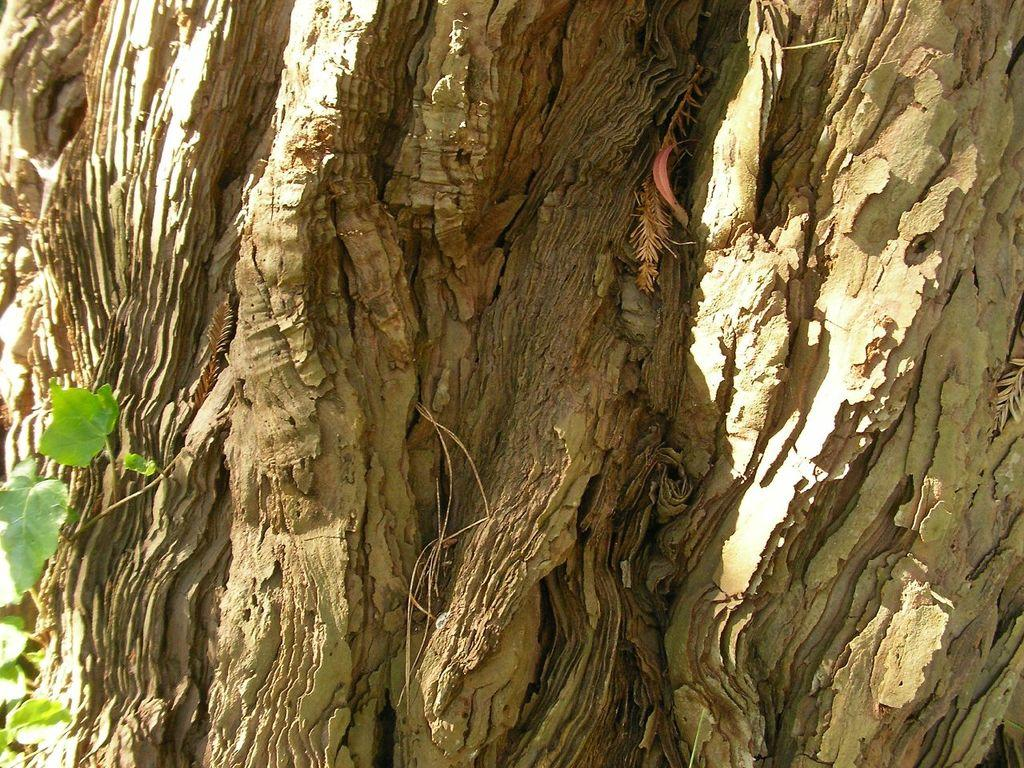What is the main subject of the image? The main subject of the image is a tree trunk. Are there any other plants or vegetation in the image? Yes, there is a plant on the left side of the image. What is the color of the tree trunk? The tree trunk is brown in color. What type of juice can be seen flowing from the tree trunk in the image? There is no juice flowing from the tree trunk in the image; it is a stationary object. 